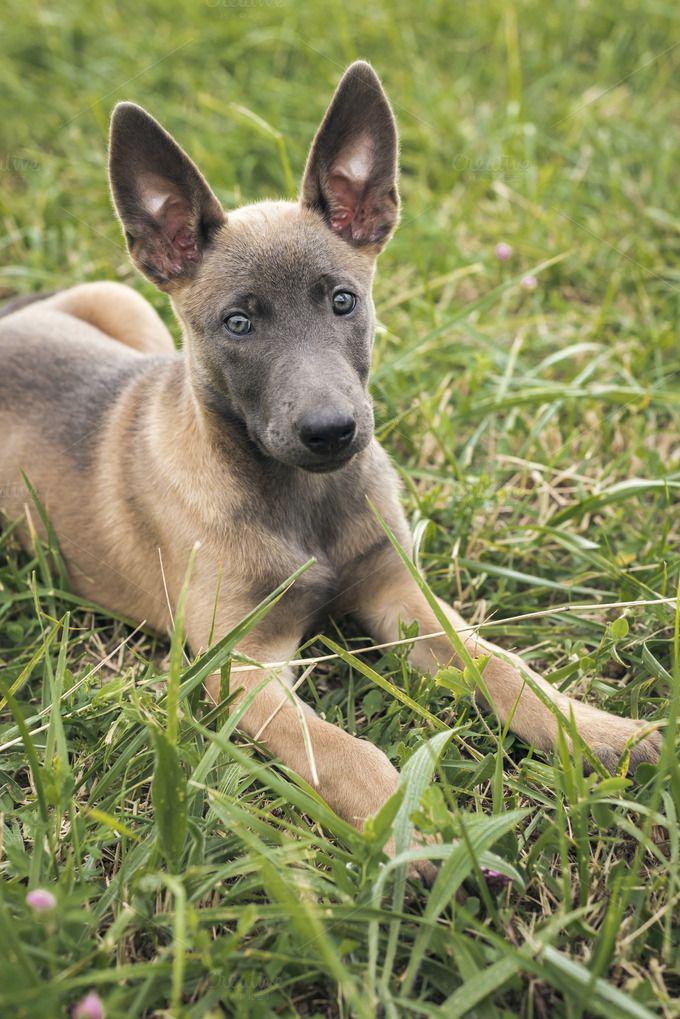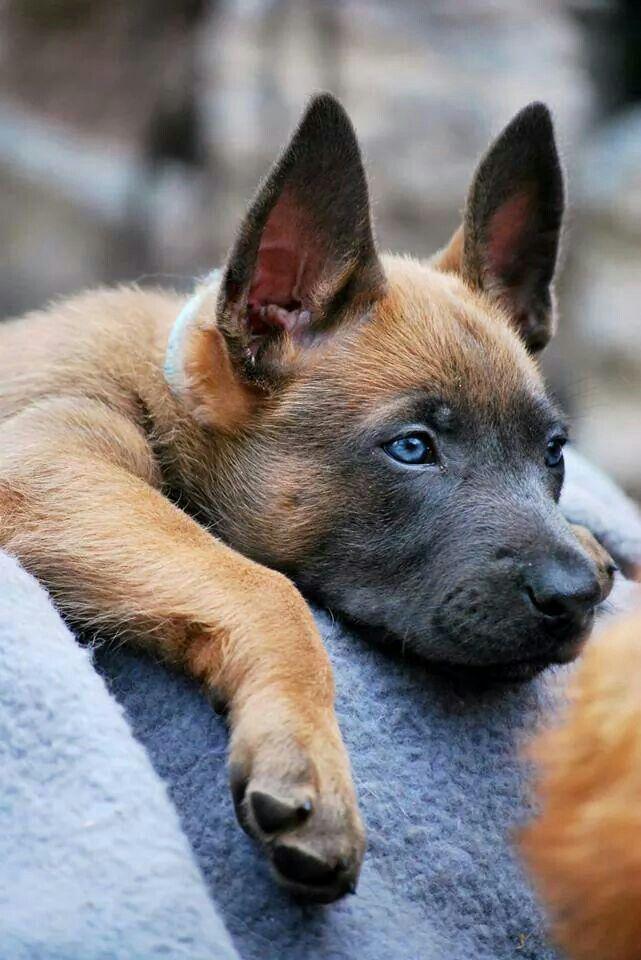The first image is the image on the left, the second image is the image on the right. Analyze the images presented: Is the assertion "The dog on the left is lying down in the grass." valid? Answer yes or no. Yes. 